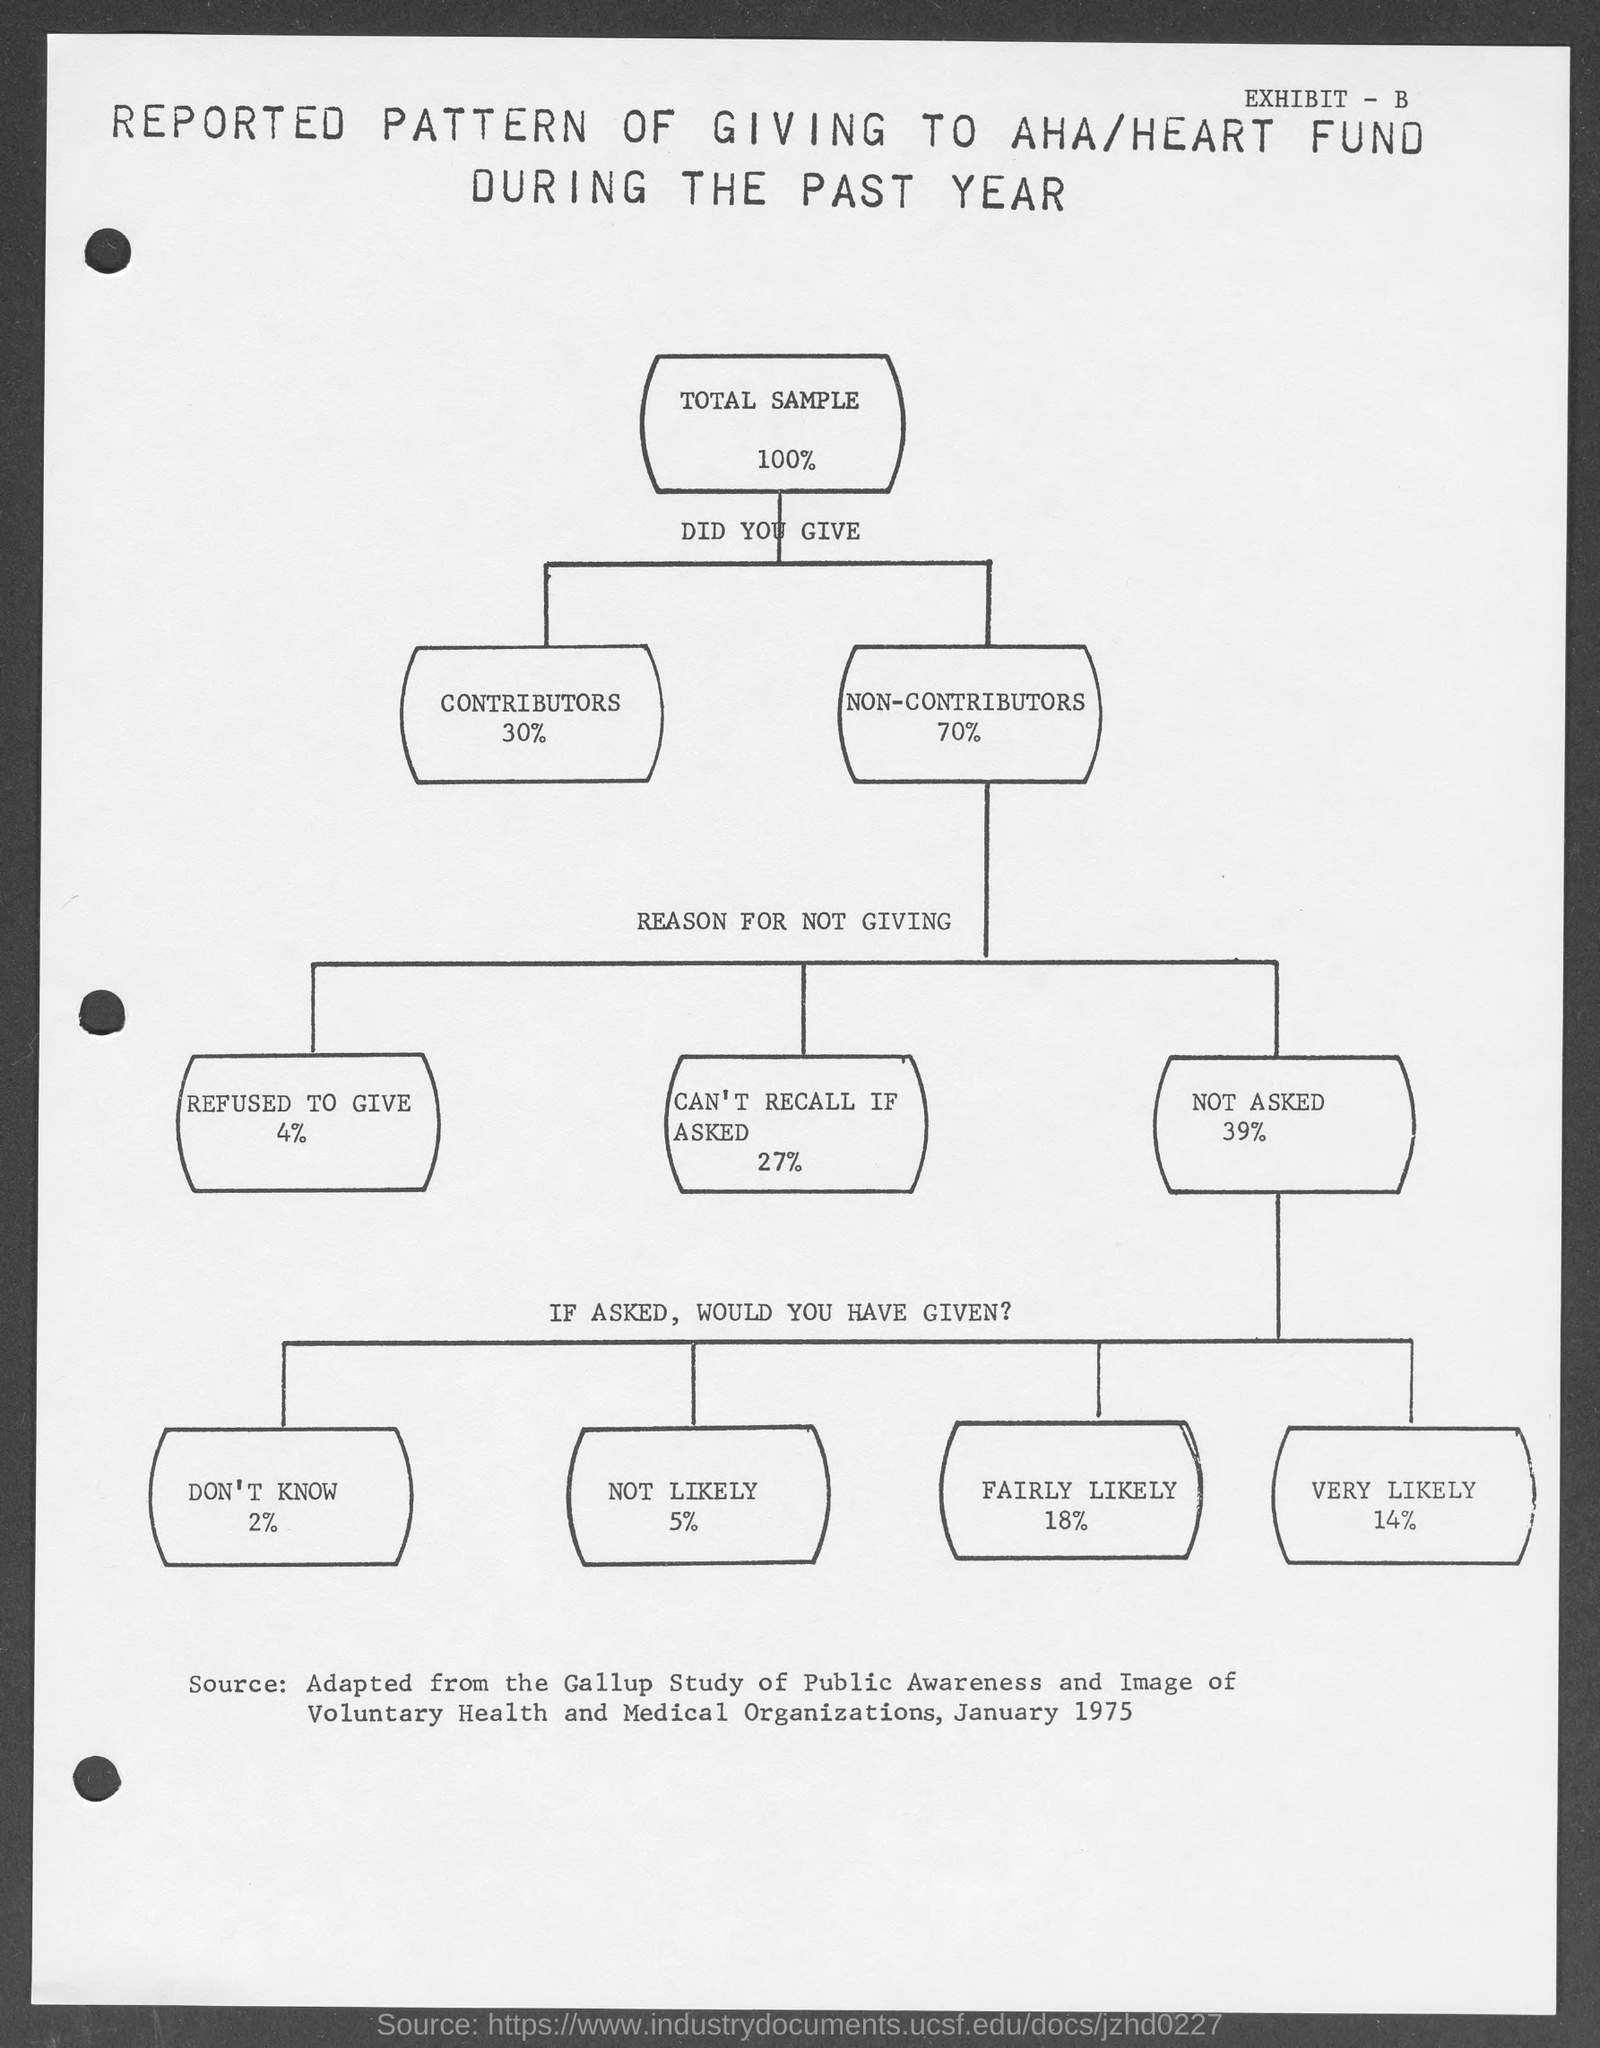List a handful of essential elements in this visual. According to the given page, 27% of members stated that they are unable to recall if asked as a reason for not giving mentioned information. According to the given page, approximately 14% of the members are very likely to contribute to the heart fund. According to the given page, approximately 5% of the members are not likely to join the heart fund. Approximately 4% of the members mentioned in the given page refused to provide the information requested. Approximately 70% of the non-contributors mentioned on the given page. 